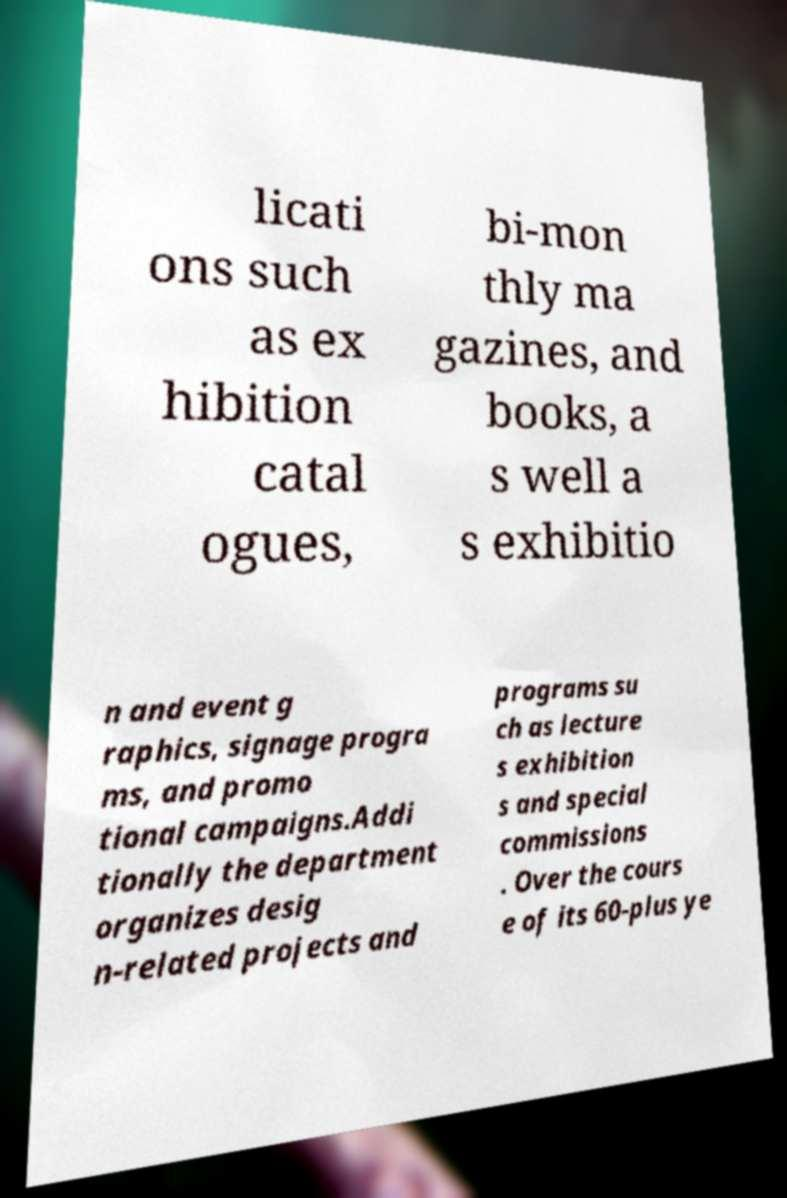What messages or text are displayed in this image? I need them in a readable, typed format. licati ons such as ex hibition catal ogues, bi-mon thly ma gazines, and books, a s well a s exhibitio n and event g raphics, signage progra ms, and promo tional campaigns.Addi tionally the department organizes desig n-related projects and programs su ch as lecture s exhibition s and special commissions . Over the cours e of its 60-plus ye 